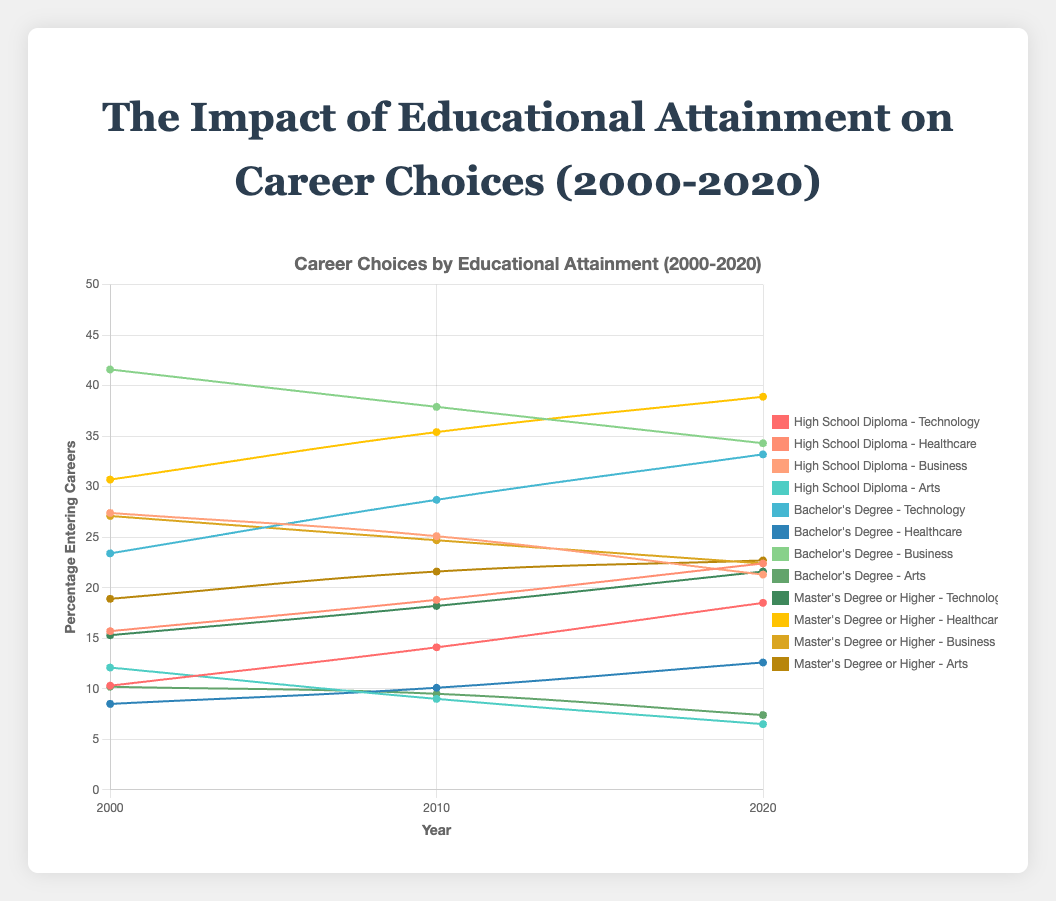Which career field had the highest percentage of Bachelor's Degree graduates in 2000? The figures for 2000 and Bachelor's Degree graduates are: Technology (23.4%), Healthcare (8.5%), Business (41.6%), and Arts (10.2%). The Business career field has the highest percentage.
Answer: Business Between 2000 and 2020, which career field saw the greatest absolute increase in percentage for those with a High School Diploma? The percentages for High School Diploma in 2000 and 2020 are: Technology (10.3% to 18.5%, increase of 8.2), Healthcare (15.7% to 22.4%, increase of 6.7), Business (27.4% to 21.3%, decrease of -6.1), and Arts (12.1% to 6.5%, decrease of -5.6). The Technology career field saw the greatest absolute increase.
Answer: Technology Which combination of year and educational level had the lowest percentage of graduates entering Arts careers? Check each group's percentage for Arts careers: High School Diploma in 2020 (6.5%) has the lowest percentage compared to all other groups and years.
Answer: High School Diploma in 2020 Calculate the combined percentage of graduates entering Technology and Healthcare careers for those with a Master's Degree or Higher in 2020. The percentages for Master's Degree or Higher in 2020 are: Technology (21.6%) and Healthcare (38.9%). Combined percentage is 21.6 + 38.9 = 60.5%.
Answer: 60.5% In 2010, which education level saw the smallest difference in percentage between graduates entering Healthcare and Business careers? Calculate the differences for 2010: High School Diploma (18.8% - 25.1% = -6.3), Bachelor's Degree (10.1% - 37.9% = -27.8), Master's Degree or Higher (35.4% - 24.7% = 10.7). The High School Diploma group has the smallest difference (-6.3).
Answer: High School Diploma Compare the trends of graduates entering Technology careers with a Bachelor's Degree from 2000 to 2020. Is there an increase or decrease? Observe the percentages for Technology with a Bachelor's Degree: 2000 (23.4%), 2010 (28.7%), and 2020 (33.2%). The trend shows an increase over the years.
Answer: Increase For 2010, identify the career field with the highest percentage of graduates with a Master's Degree or Higher. The percentages for Master's Degree or Higher in 2010 are: Technology (18.2%), Healthcare (35.4%), Business (24.7%), and Arts (21.6%). Healthcare has the highest percentage.
Answer: Healthcare Determine the overall trend for graduates entering Arts careers from 2000 to 2020 for those with a High School Diploma. The percentages for Arts with a High School Diploma are: 2000 (12.1%), 2010 (9.0%), and 2020 (6.5%). The trend shows a consistent decrease over the years.
Answer: Decrease 